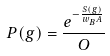Convert formula to latex. <formula><loc_0><loc_0><loc_500><loc_500>P ( g ) = \frac { e ^ { - \frac { S ( g ) } { w _ { B } A } } } { O }</formula> 